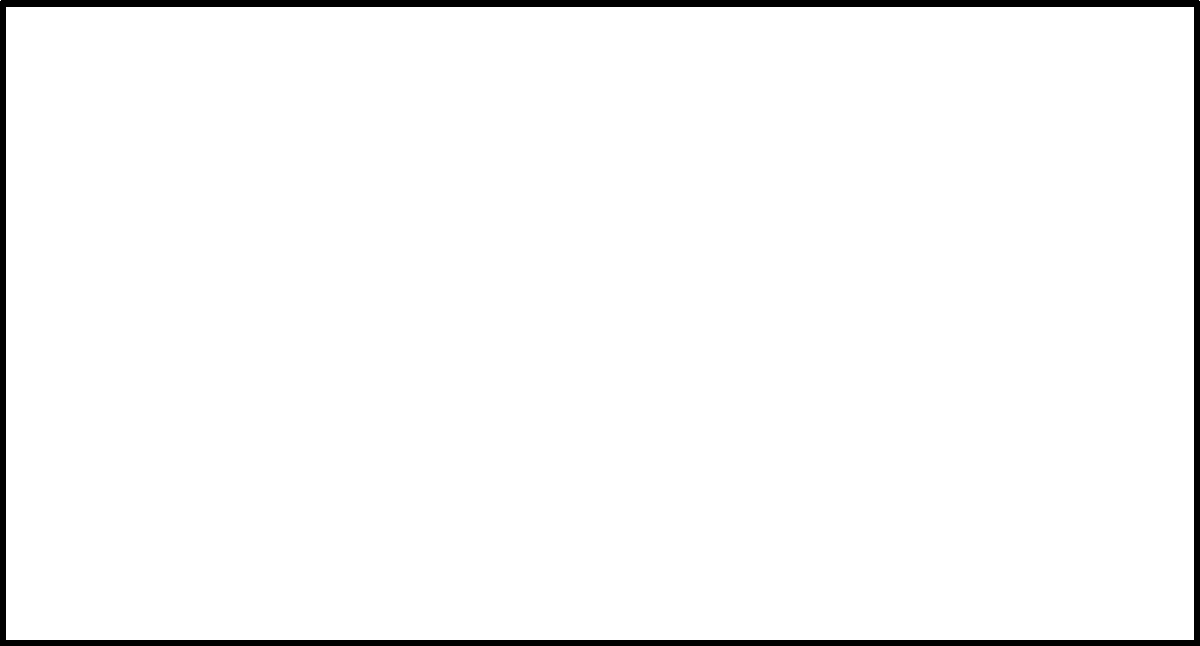As a coach, you're overseeing the renovation of your team's outdoor basketball court. The court measures 28 m by 15 m and needs a new drainage system. The design includes a 1% slope along the length and a 2% slope along the width, as shown in the diagram. If the expected maximum rainfall intensity is 50 mm/hr, what is the minimum required capacity of the drainage system in liters per second? Let's approach this step-by-step:

1) First, calculate the surface area of the court:
   $A = 28 \text{ m} \times 15 \text{ m} = 420 \text{ m}^2$

2) Convert the rainfall intensity from mm/hr to m/s:
   $50 \text{ mm/hr} = 50 \times \frac{1}{1000} \times \frac{1}{3600} \text{ m/s} = 1.389 \times 10^{-5} \text{ m/s}$

3) Calculate the volume of water falling on the court per second:
   $V = A \times \text{rainfall intensity}$
   $V = 420 \text{ m}^2 \times 1.389 \times 10^{-5} \text{ m/s} = 5.833 \times 10^{-3} \text{ m}^3/\text{s}$

4) Convert this volume to liters per second:
   $5.833 \times 10^{-3} \text{ m}^3/\text{s} = 5.833 \text{ L/s}$

5) To ensure proper drainage, we should add a safety factor. A common practice is to increase the capacity by 20%:
   $5.833 \text{ L/s} \times 1.2 = 7 \text{ L/s}$

Therefore, the minimum required capacity of the drainage system should be 7 L/s.
Answer: 7 L/s 